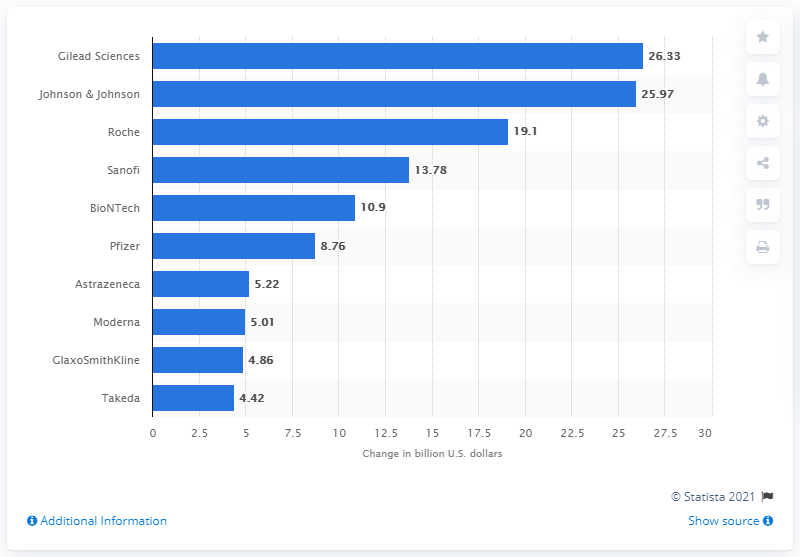Highlight a few significant elements in this photo. As of May 27, 2020, Gilead Sciences' market capitalization was 26.33... 